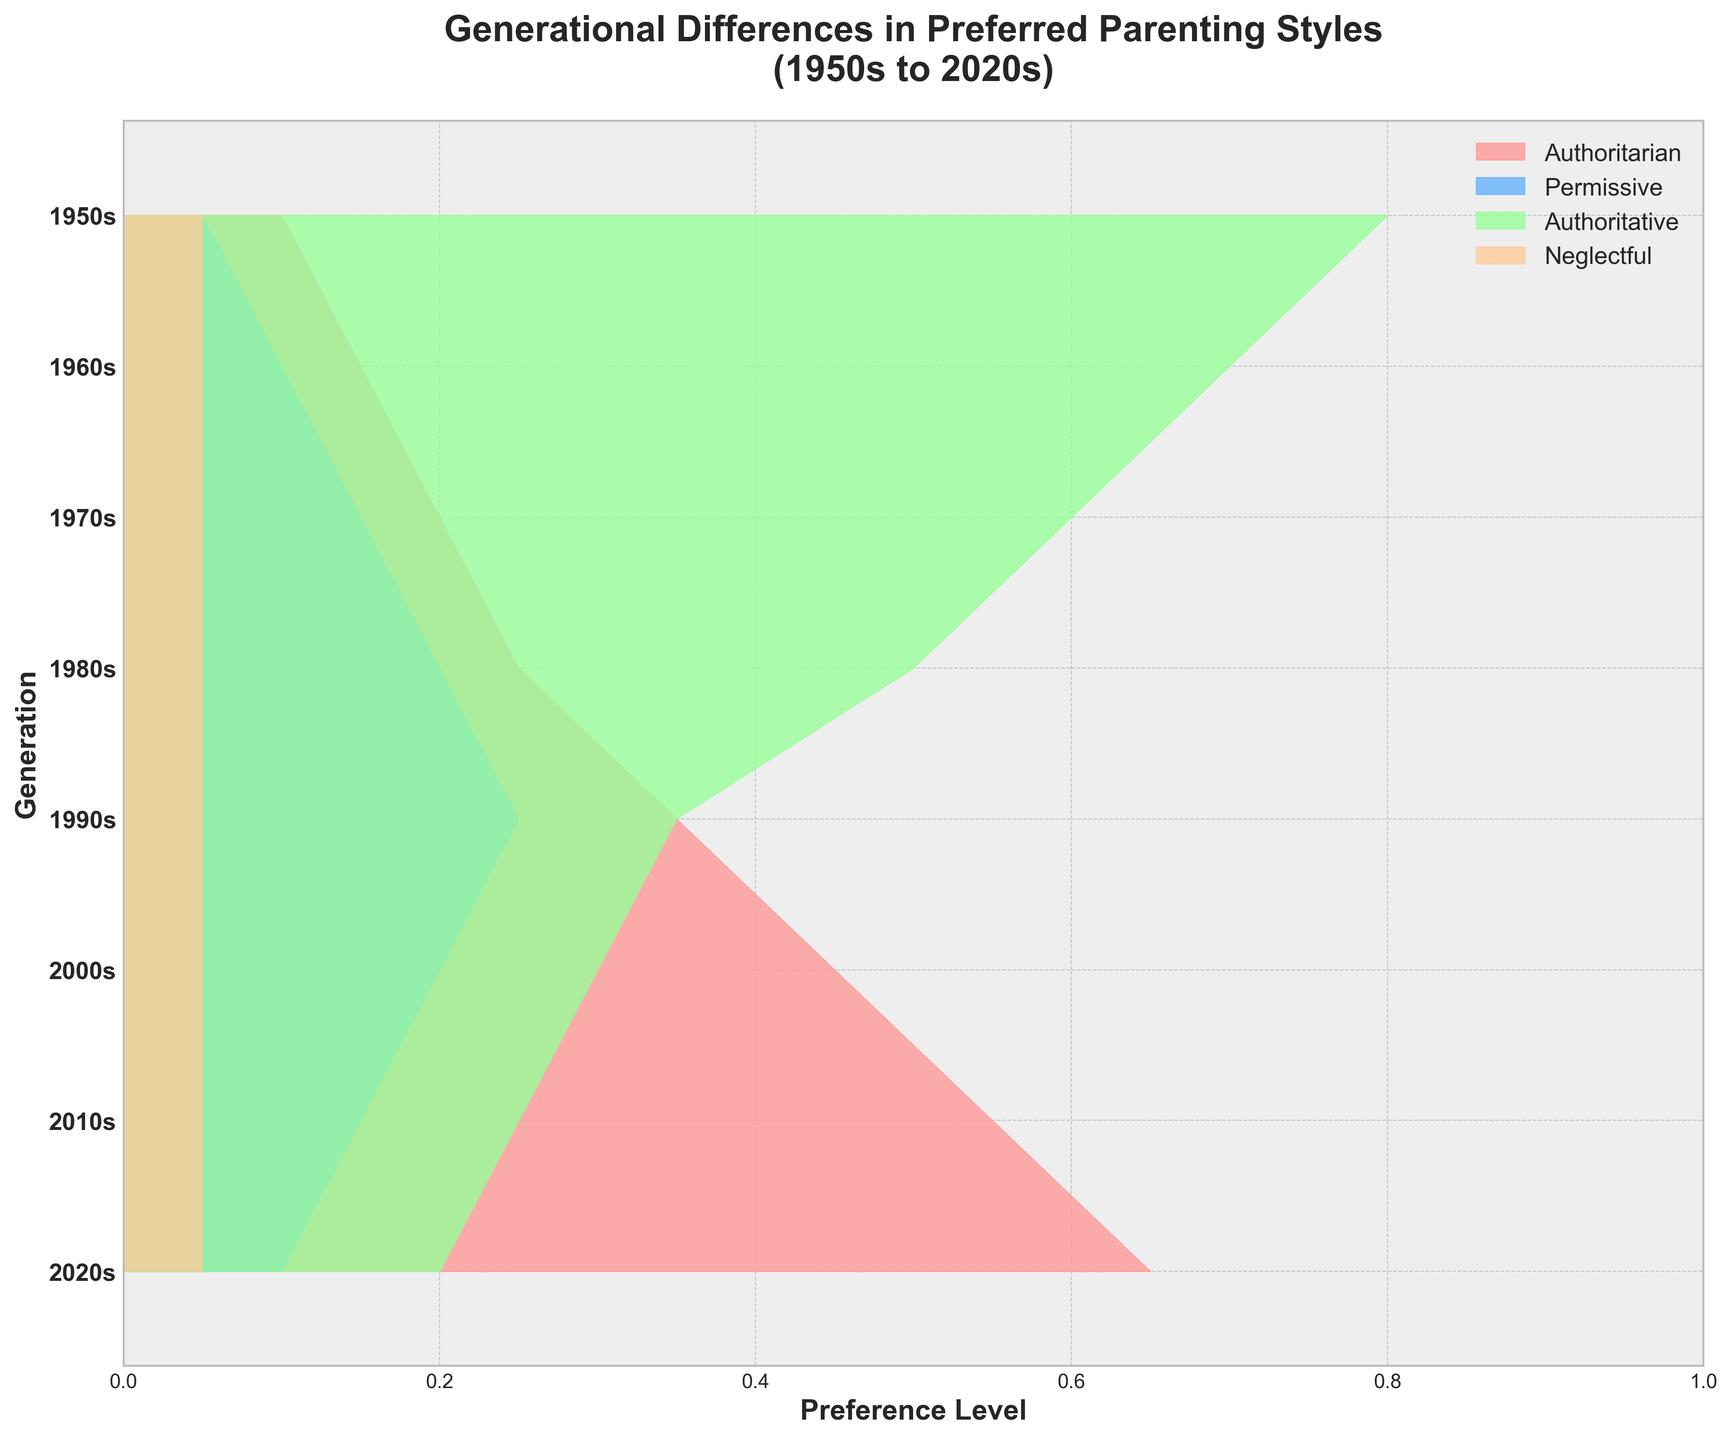What is the title of the chart? The title is at the top of the chart, which typically summarizes the main focus or outcome of the visualization.
Answer: Generational Differences in Preferred Parenting Styles (1950s to 2020s) How many generations are represented in the chart? The y-axis of the chart lists each generation from the 1950s to the 2020s, with each line representing one generation. Counting these lines gives us the total number of generations.
Answer: 8 Which parenting style shows the greatest increase in preference over the generations? By examining the filled areas for each parenting style from the 1950s to the 2020s, we can see which color occupies more space in recent years compared to earlier ones.
Answer: Authoritative In the 1980s, which parenting style had the lowest preference level? By locating the 1980s on the y-axis and examining the corresponding filled areas, we can identify the parenting style with the smallest area.
Answer: Neglectful Compare the preference level of the Authoritarian style between the 1950s and the 2020s. Which one is higher and by how much? The filled area for the Authoritarian style in the 1950s and 2020s can be compared directly using the visual lengths. The difference can then be calculated.
Answer: 1950s is higher by 0.55 What is the preference level range of the Permissive style from the 1950s to the 2020s? By examining the filled areas for the Permissive style across all generations, we can determine the highest and lowest levels of preference and find the range by subtracting the lowest from the highest.
Answer: 0.1 (1960s) to 0.25 (1980s) = 0.15 Between the 1970s and 2000s, how did the preference for Permissive and Authoritative styles change? By examining the filled areas for these two parenting styles in the 1970s and 2000s, we can compare their changes in preference levels.
Answer: Permissive decreases by 0.05, Authoritative increases by 0.30 Which generation shows an equal preference for Authoritarian and Authoritative styles? By looking for the generation where the filled areas for both Authoritarian and Authoritative styles are equal, we find the relevant point.
Answer: No generation shows an equal preference 